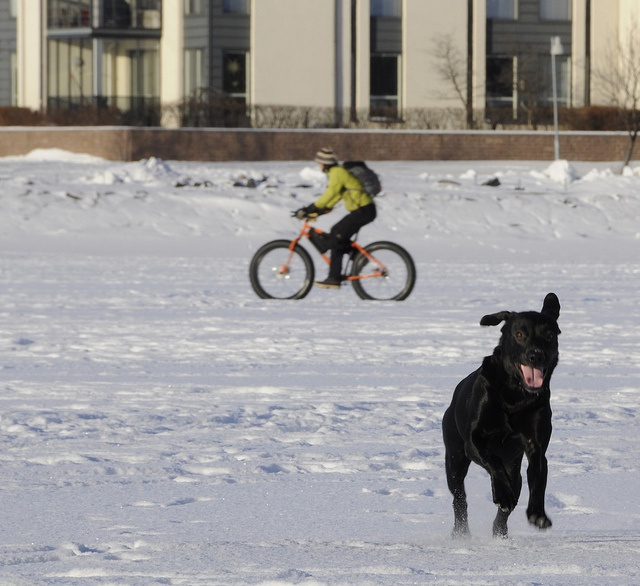Describe the objects in this image and their specific colors. I can see dog in gray, black, and darkgray tones, bicycle in gray, darkgray, and black tones, people in gray, black, and olive tones, and backpack in gray, black, and darkgreen tones in this image. 